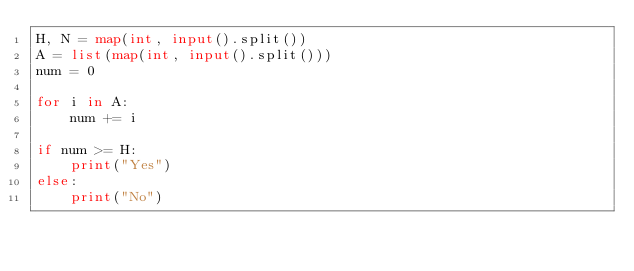<code> <loc_0><loc_0><loc_500><loc_500><_Python_>H, N = map(int, input().split())
A = list(map(int, input().split()))
num = 0

for i in A:
    num += i

if num >= H:
    print("Yes")
else:
    print("No")</code> 